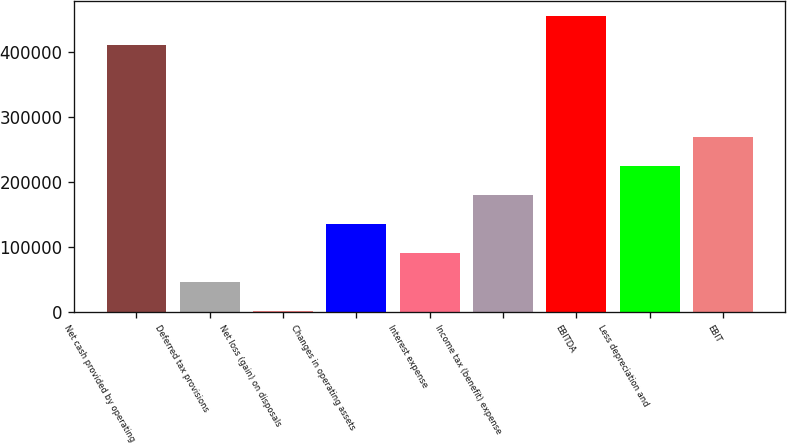Convert chart. <chart><loc_0><loc_0><loc_500><loc_500><bar_chart><fcel>Net cash provided by operating<fcel>Deferred tax provisions<fcel>Net loss (gain) on disposals<fcel>Changes in operating assets<fcel>Interest expense<fcel>Income tax (benefit) expense<fcel>EBITDA<fcel>Less depreciation and<fcel>EBIT<nl><fcel>411646<fcel>46635<fcel>1980<fcel>135945<fcel>91290<fcel>180600<fcel>456301<fcel>225255<fcel>269910<nl></chart> 